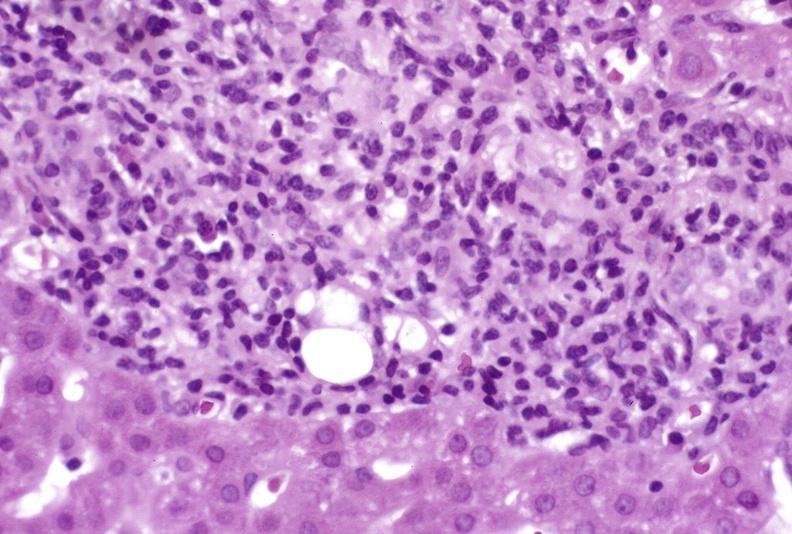s leiomyomas present?
Answer the question using a single word or phrase. No 